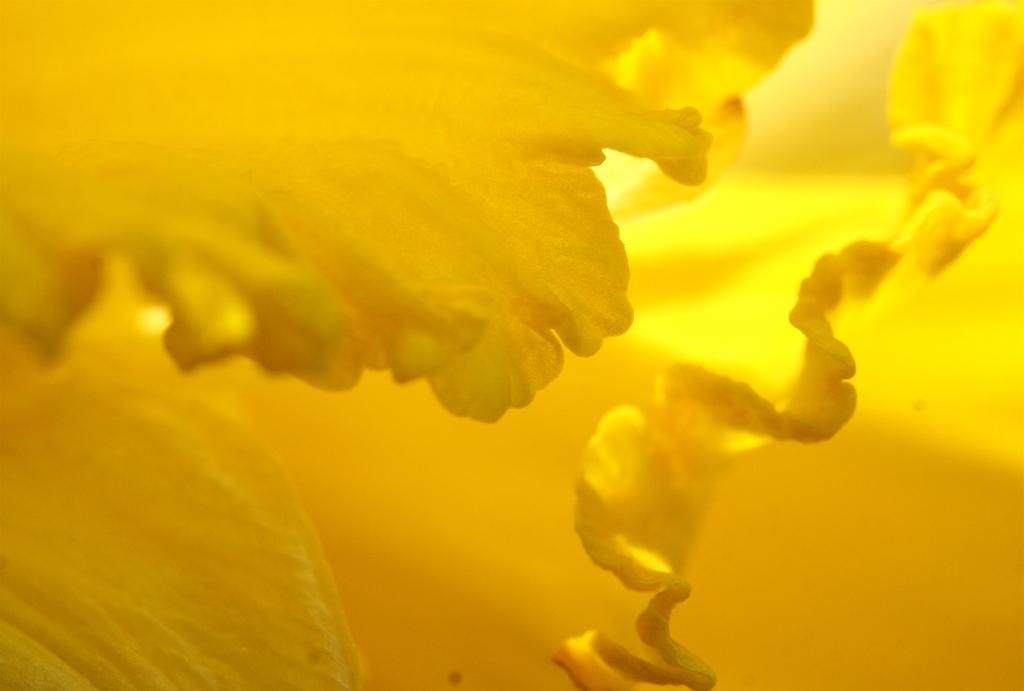What is present in the image? There are petals of a flower in the image. What color are the petals? The petals are yellow in color. What type of furniture can be seen in the image? There is no furniture present in the image; it only features petals of a flower. 